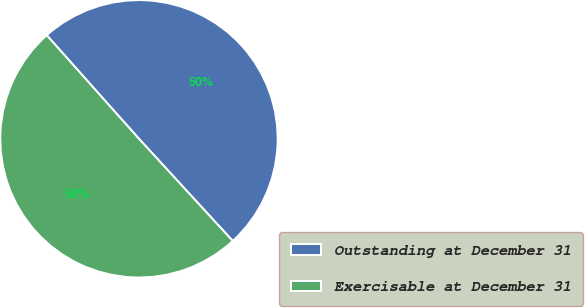<chart> <loc_0><loc_0><loc_500><loc_500><pie_chart><fcel>Outstanding at December 31<fcel>Exercisable at December 31<nl><fcel>49.76%<fcel>50.24%<nl></chart> 